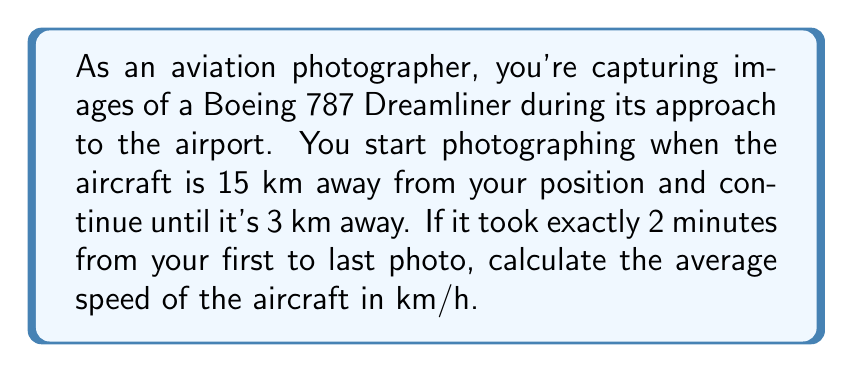Give your solution to this math problem. To solve this problem, we'll use the formula for average speed:

$$ \text{Average Speed} = \frac{\text{Distance Traveled}}{\text{Time Taken}} $$

Let's break down the given information:
1. Initial distance: 15 km
2. Final distance: 3 km
3. Time taken: 2 minutes

First, we need to calculate the distance traveled:
$$ \text{Distance Traveled} = \text{Initial Distance} - \text{Final Distance} $$
$$ \text{Distance Traveled} = 15 \text{ km} - 3 \text{ km} = 12 \text{ km} $$

Now, we need to convert the time from minutes to hours:
$$ 2 \text{ minutes} = \frac{2}{60} \text{ hours} = \frac{1}{30} \text{ hours} $$

We can now plug these values into our average speed formula:

$$ \text{Average Speed} = \frac{12 \text{ km}}{\frac{1}{30} \text{ hours}} $$

To simplify this fraction, we multiply both numerator and denominator by 30:

$$ \text{Average Speed} = \frac{12 \times 30 \text{ km}}{1 \text{ hour}} = 360 \text{ km/h} $$

Therefore, the average speed of the Boeing 787 Dreamliner during your photo session was 360 km/h.
Answer: 360 km/h 